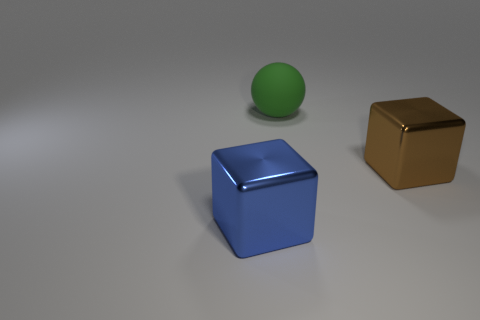Is there anything else that has the same material as the big sphere?
Offer a terse response. No. There is a thing in front of the brown thing; what shape is it?
Your response must be concise. Cube. There is a cube right of the big green object; is it the same color as the large metallic cube to the left of the rubber object?
Your response must be concise. No. How many things are both in front of the large sphere and to the left of the big brown metal thing?
Offer a terse response. 1. The other block that is the same material as the big blue cube is what size?
Provide a succinct answer. Large. What is the size of the green matte thing?
Provide a short and direct response. Large. What is the material of the big green thing?
Offer a very short reply. Rubber. Does the shiny object right of the rubber object have the same size as the large matte ball?
Offer a terse response. Yes. How many things are big metallic blocks or green objects?
Ensure brevity in your answer.  3. What size is the object that is both behind the blue thing and in front of the green thing?
Ensure brevity in your answer.  Large. 